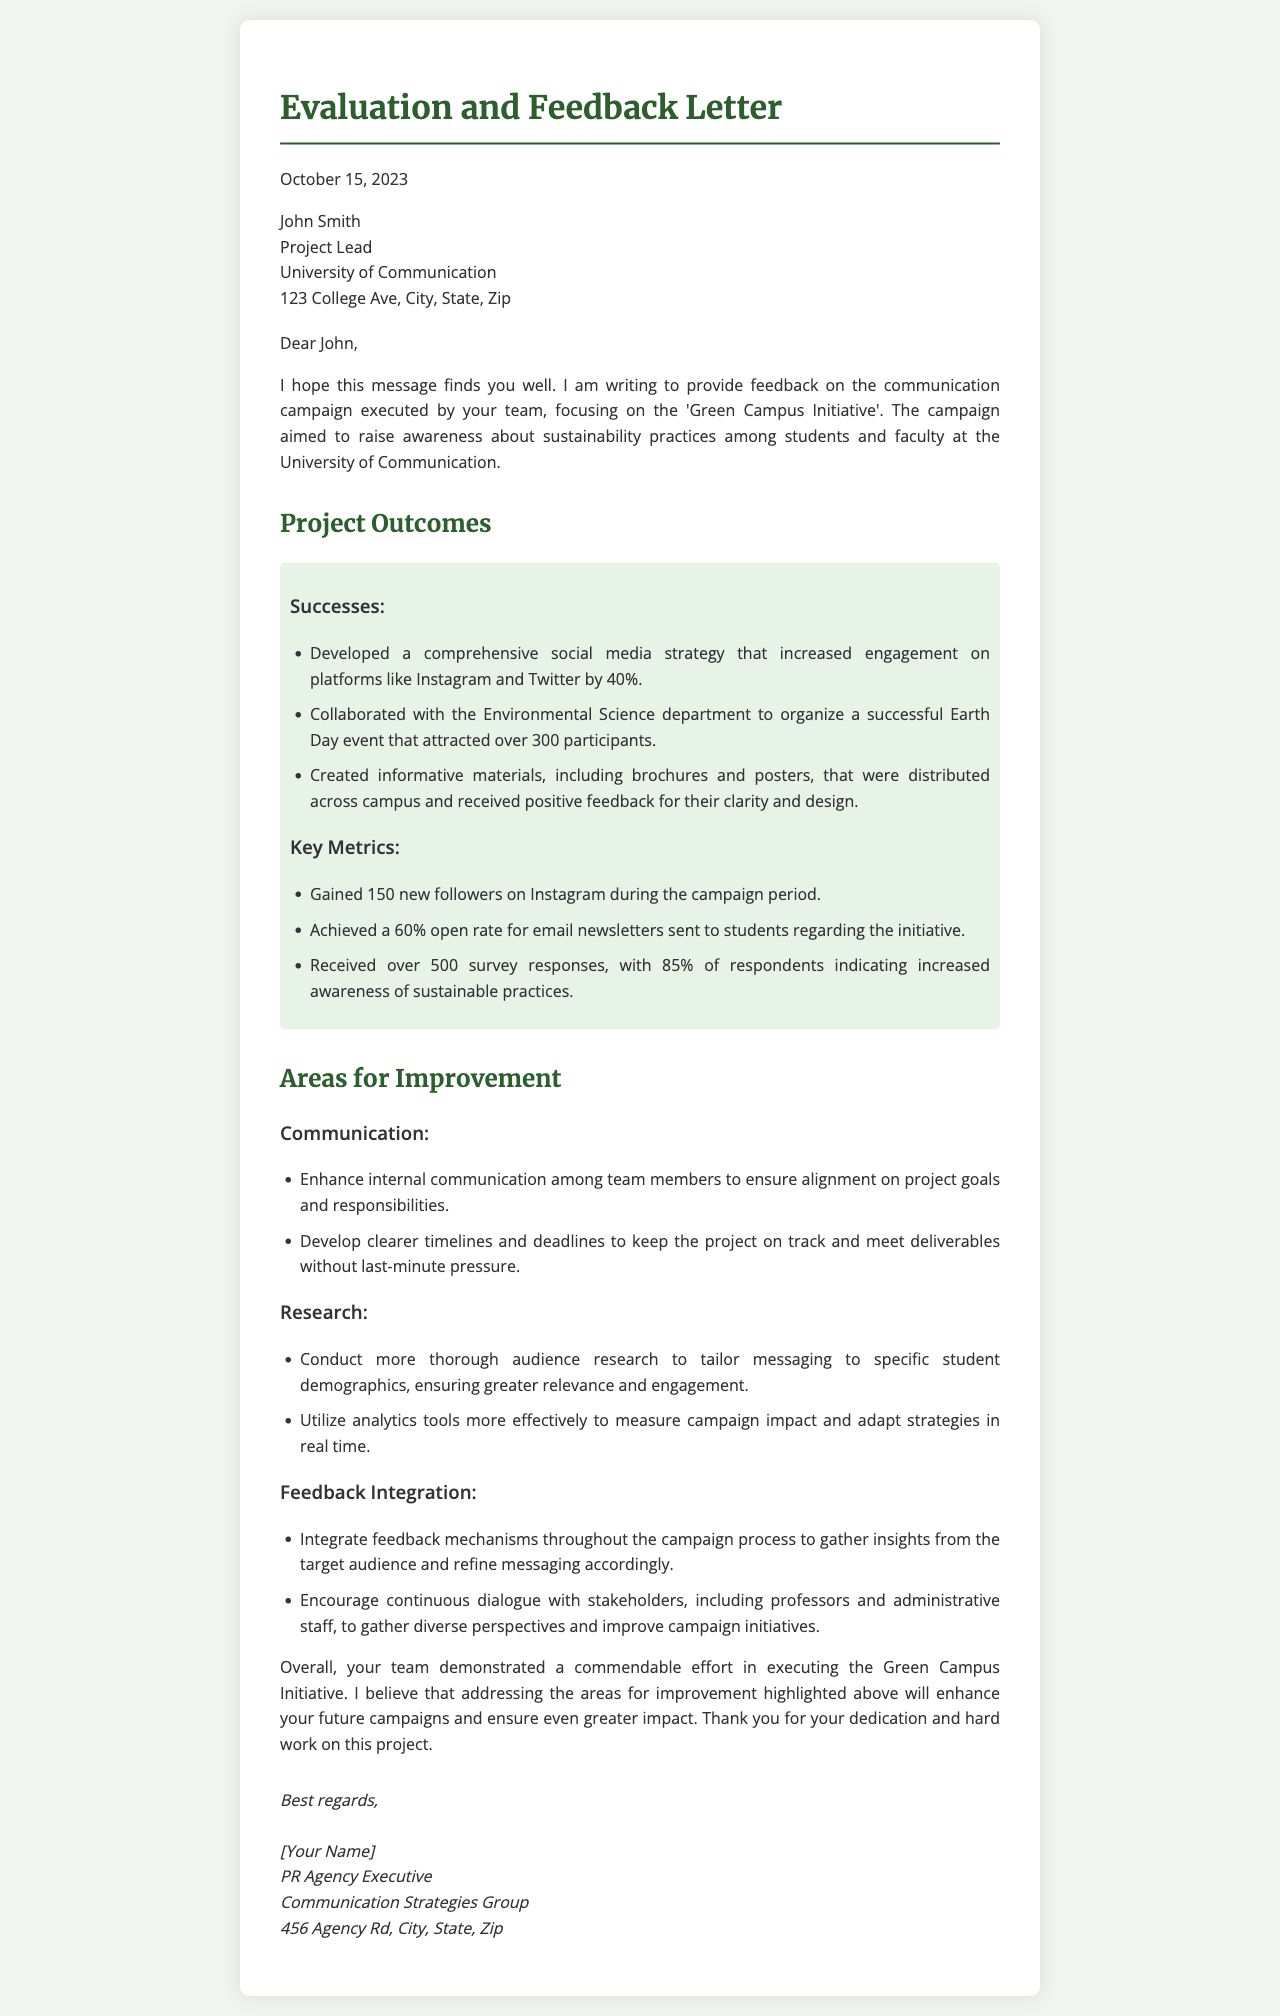What is the date of the letter? The date of the letter is stated at the beginning of the document, which is October 15, 2023.
Answer: October 15, 2023 Who is the recipient of the letter? The recipient's details are listed in the document; the name is John Smith.
Answer: John Smith What was the campaign focused on? The campaign is described in the letter as the 'Green Campus Initiative'.
Answer: Green Campus Initiative How much did Instagram engagement increase by? The document specifies that engagement on platforms like Instagram increased by 40%.
Answer: 40% What percentage of survey respondents indicated increased awareness of sustainable practices? This information can be found in the key metrics section, indicating that 85% of respondents showed increased awareness.
Answer: 85% What is one area for improvement mentioned in the letter? The document lists multiple areas for improvement, such as enhancing internal communication among team members.
Answer: Enhance internal communication What was the turnout for the Earth Day event? The document mentions that the Earth Day event attracted over 300 participants.
Answer: over 300 Who authored the letter? The author's name is provided at the end of the letter, which is [Your Name].
Answer: [Your Name] What is the organization of the author? The author identifies their organization as the Communication Strategies Group in the signature section.
Answer: Communication Strategies Group 